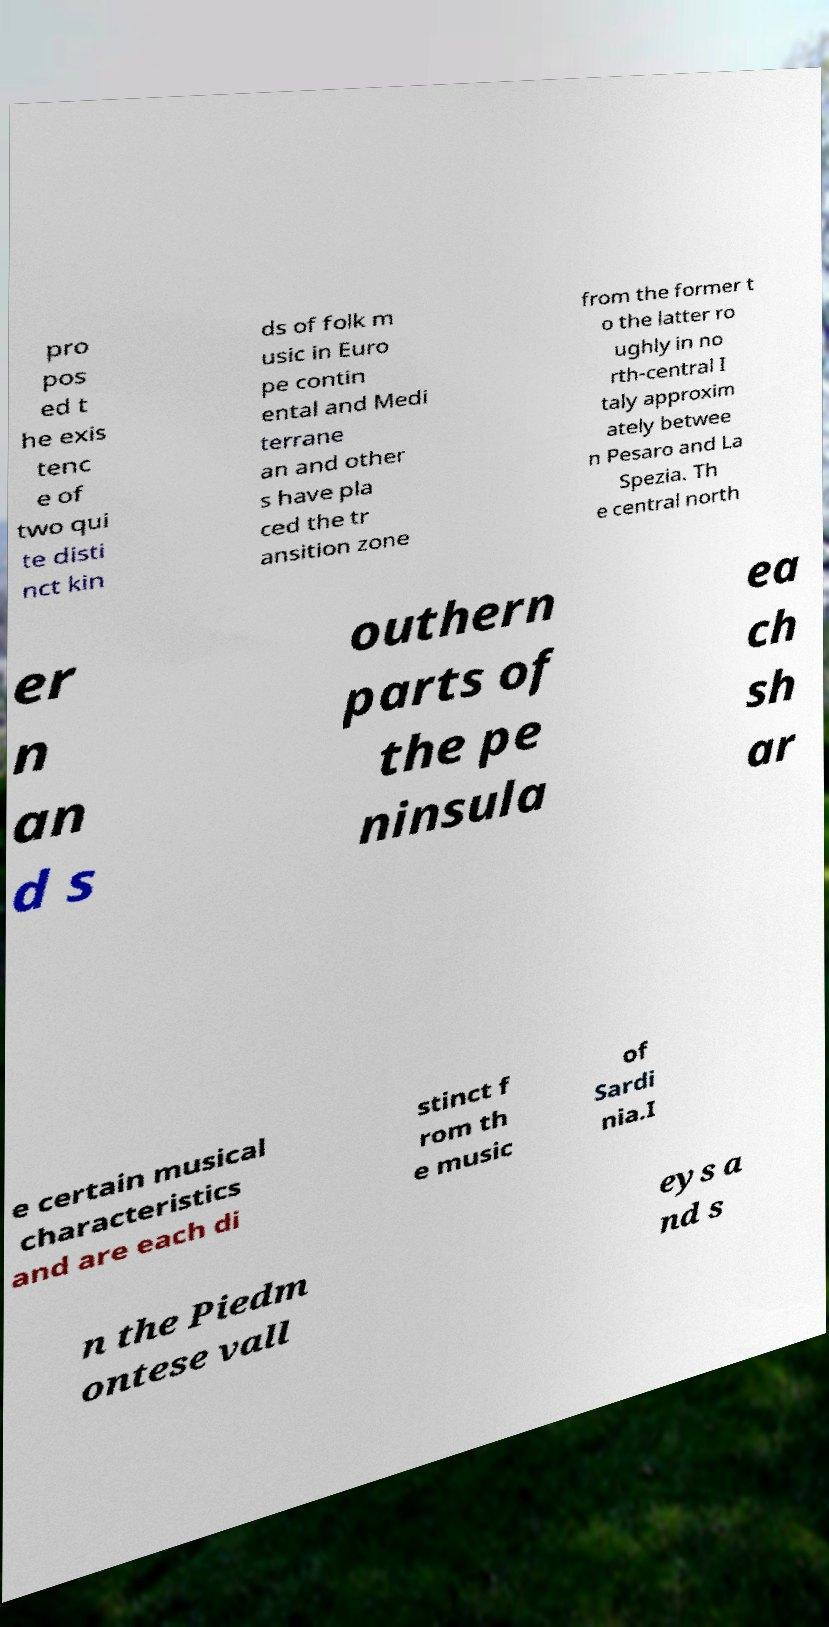What messages or text are displayed in this image? I need them in a readable, typed format. pro pos ed t he exis tenc e of two qui te disti nct kin ds of folk m usic in Euro pe contin ental and Medi terrane an and other s have pla ced the tr ansition zone from the former t o the latter ro ughly in no rth-central I taly approxim ately betwee n Pesaro and La Spezia. Th e central north er n an d s outhern parts of the pe ninsula ea ch sh ar e certain musical characteristics and are each di stinct f rom th e music of Sardi nia.I n the Piedm ontese vall eys a nd s 